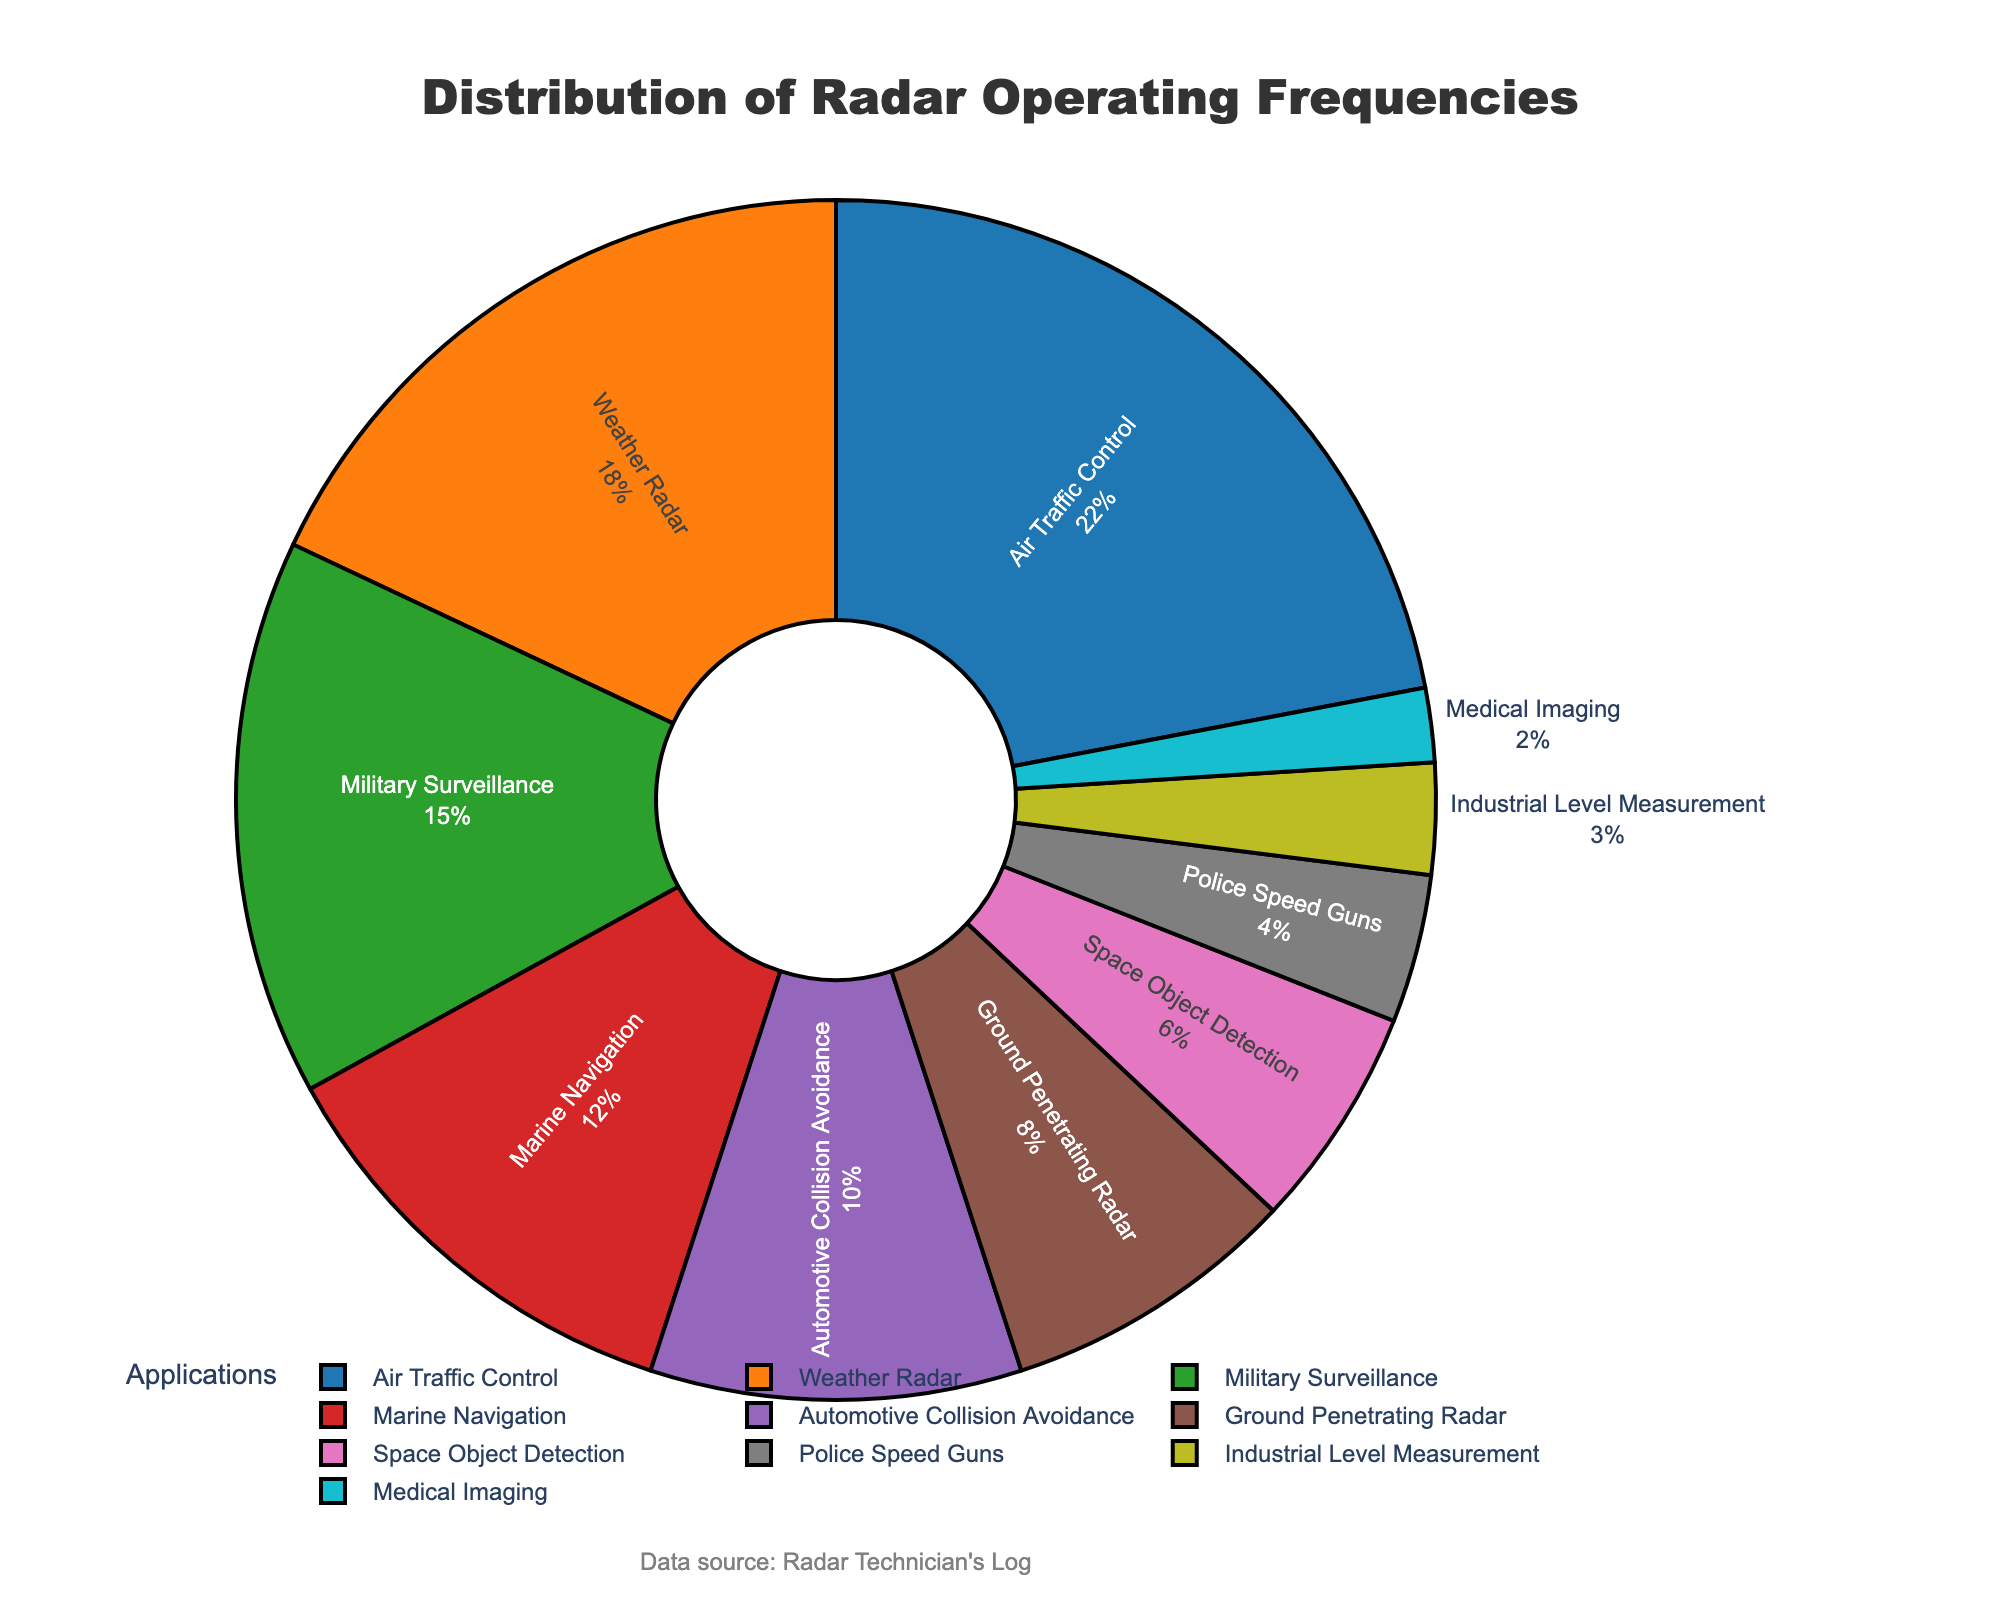What's the application with the highest radar operating frequency? By visually inspecting the pie chart, the application segment that occupies the largest portion indicates the highest frequency percentage.
Answer: Air Traffic Control Which application has a lower operating frequency, Marine Navigation or Military Surveillance? Visually compare the sizes of the pie segments labeled "Marine Navigation" and "Military Surveillance". Marine Navigation has a smaller segment.
Answer: Marine Navigation What's the combined frequency percentage of Automotive Collision Avoidance and Ground Penetrating Radar applications? Identify the percentages for Automotive Collision Avoidance (10%) and Ground Penetrating Radar (8%) on the pie chart, then sum them up: 10% + 8% = 18%.
Answer: 18% Is Space Object Detection's frequency percentage less than that of Weather Radar? Compare the sizes of the segments labeled "Space Object Detection" and "Weather Radar". Space Object Detection's segment is smaller.
Answer: Yes How many applications have operating frequencies greater than 10%? Identify all segments with percentages greater than 10%: Air Traffic Control (22%), Weather Radar (18%), Military Surveillance (15%), Marine Navigation (12%). Count these segments.
Answer: Four What is the difference in frequency percentage between the largest and smallest applications? The largest application is Air Traffic Control (22%) and the smallest is Medical Imaging (2%). Calculate the difference: 22% - 2% = 20%.
Answer: 20% Which applications have their frequencies represented by darker colors (assuming the color palette has darker and lighter shades)? Visually inspect the pie chart to see which applications are shaded with the darker colors (typically the first half of the palette, like blue, orange, green, and red).
Answer: Air Traffic Control, Weather Radar, Military Surveillance, Marine Navigation What's the combined percentage of the four applications with the smallest operating frequencies? Identify the smallest frequencies: Medical Imaging (2%), Industrial Level Measurement (3%), Police Speed Guns (4%), and Space Object Detection (6%). Sum them: 2% + 3% + 4% + 6% = 15%.
Answer: 15% What percentage slice does Marine Navigation occupy in the pie chart? Locate the "Marine Navigation" segment in the pie chart and refer to its labeled percentage.
Answer: 12% Is the frequency for Weather Radar greater than double the frequency for Ground Penetrating Radar? Compare Weather Radar's frequency (18%) to double the Ground Penetrating Radar's frequency (2*8% = 16%). 18% is greater than 16%.
Answer: Yes 